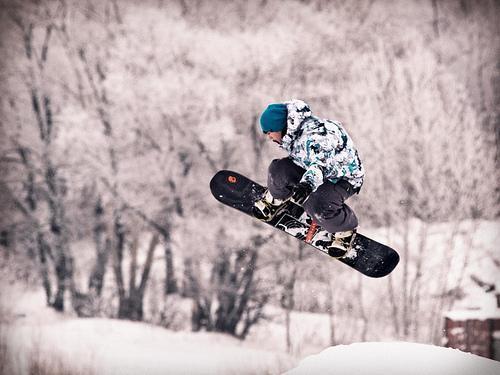How many people are shown?
Give a very brief answer. 1. 